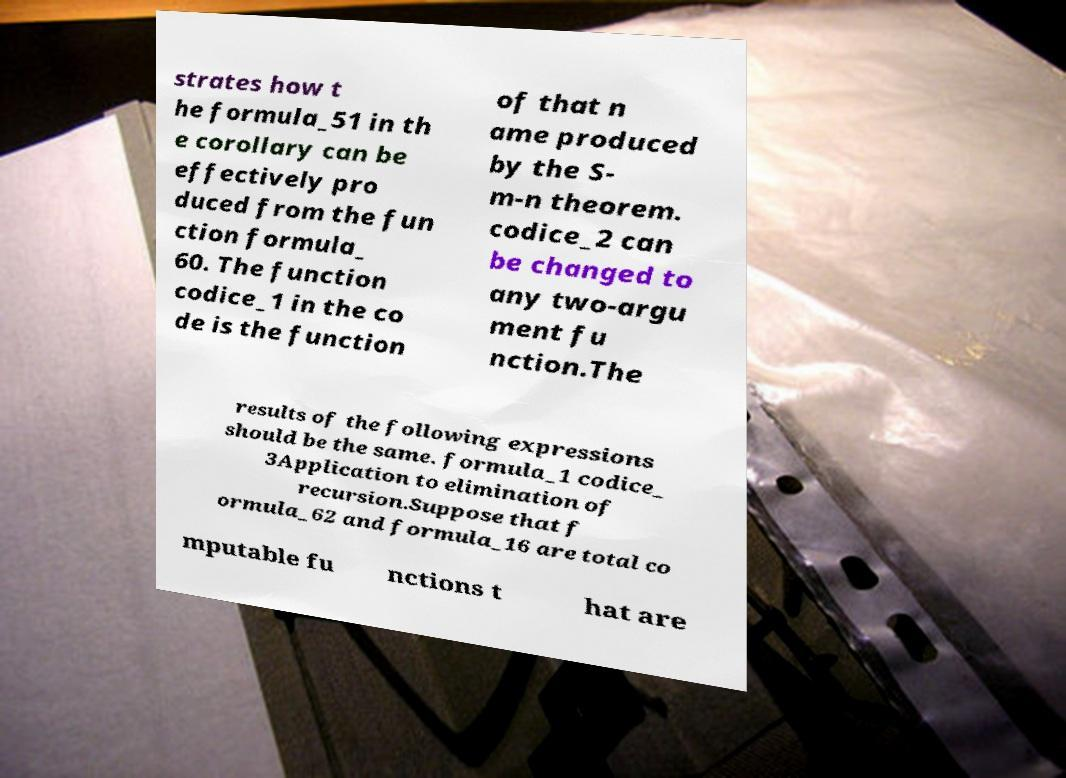What messages or text are displayed in this image? I need them in a readable, typed format. strates how t he formula_51 in th e corollary can be effectively pro duced from the fun ction formula_ 60. The function codice_1 in the co de is the function of that n ame produced by the S- m-n theorem. codice_2 can be changed to any two-argu ment fu nction.The results of the following expressions should be the same. formula_1 codice_ 3Application to elimination of recursion.Suppose that f ormula_62 and formula_16 are total co mputable fu nctions t hat are 